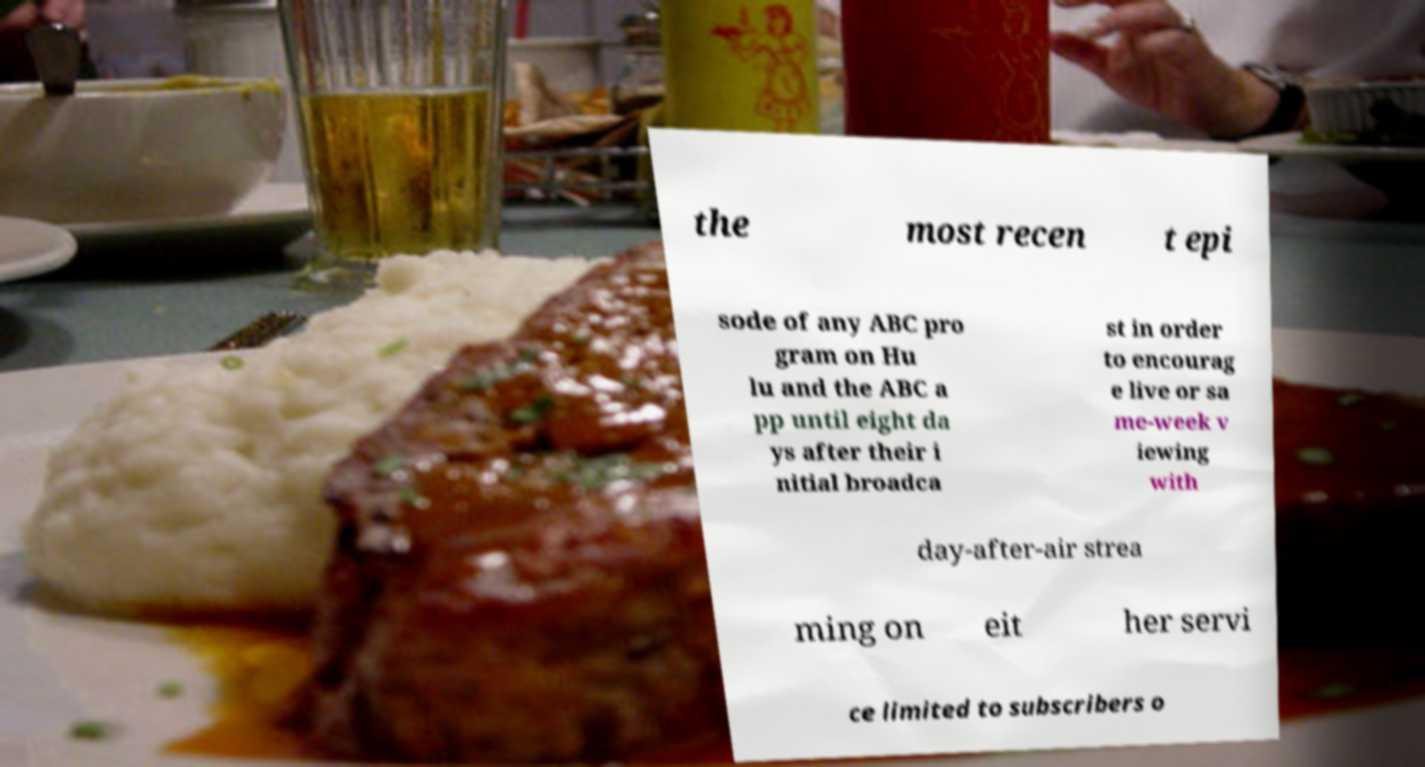What messages or text are displayed in this image? I need them in a readable, typed format. the most recen t epi sode of any ABC pro gram on Hu lu and the ABC a pp until eight da ys after their i nitial broadca st in order to encourag e live or sa me-week v iewing with day-after-air strea ming on eit her servi ce limited to subscribers o 